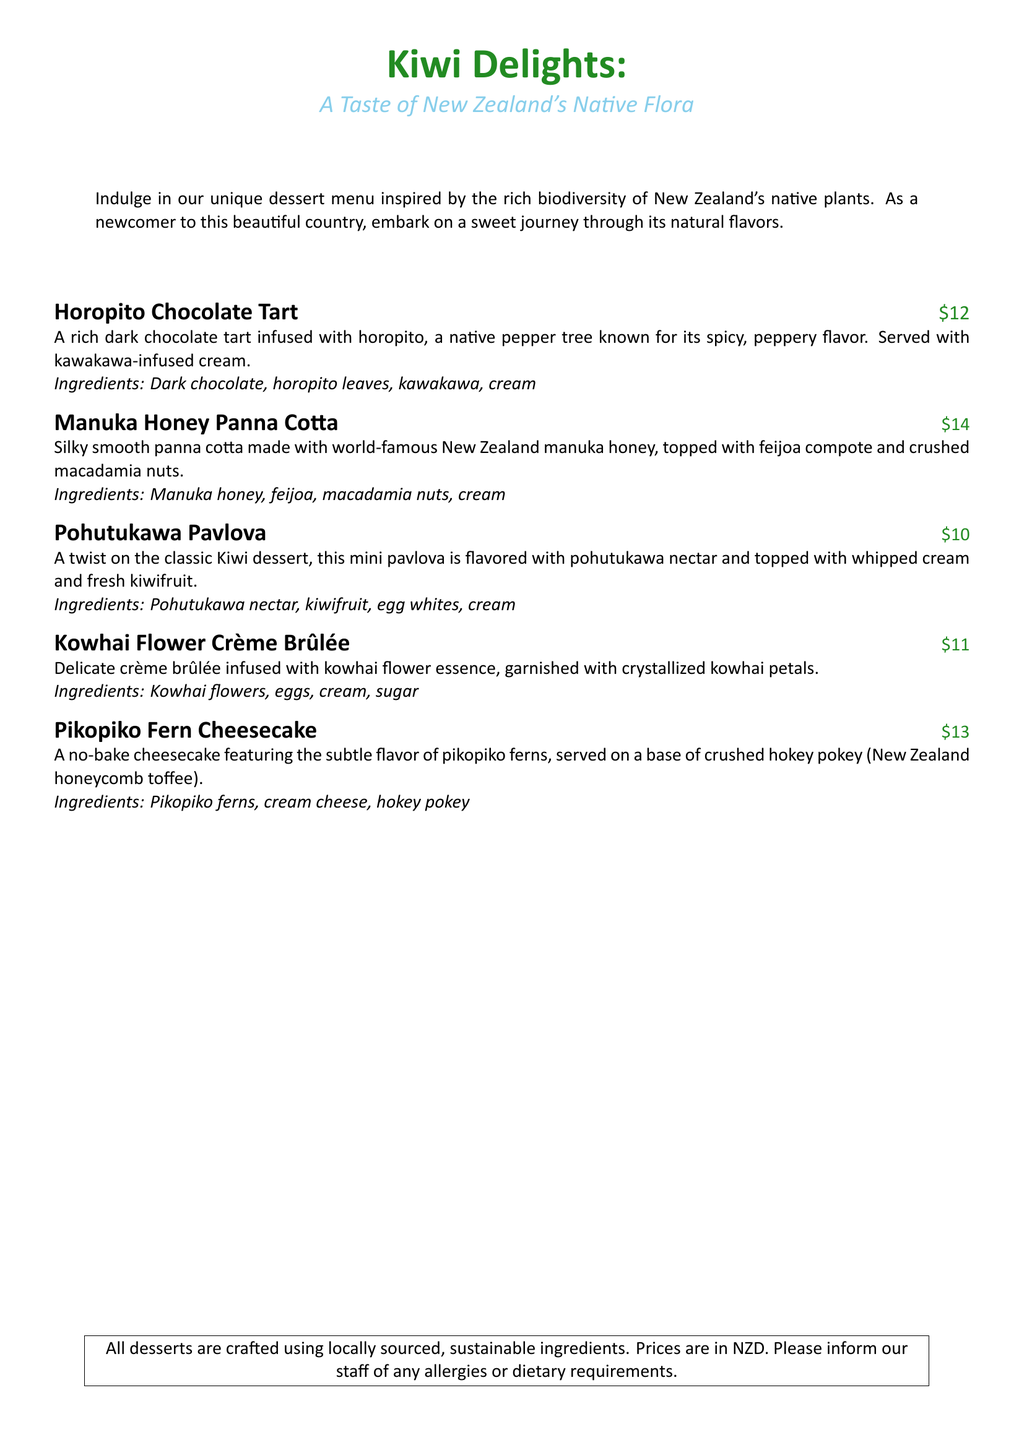what is the price of the Horopito Chocolate Tart? The price can be found next to the dessert name in the menu.
Answer: $12 which native plant is used in the Manuka Honey Panna Cotta? This dessert features world-famous New Zealand manuka honey as its key ingredient.
Answer: manuka honey what are the main ingredients of the Kowhai Flower Crème Brûlée? The ingredients for this dessert are listed after the description.
Answer: kowhai flowers, eggs, cream, sugar how is the Pohutukawa Pavlova different from the classic version? The description mentions a twist flavoring with a specific native nectar.
Answer: pohutukawa nectar what is the base ingredient used in the Pikopiko Fern Cheesecake? The menu specifies that this cheesecake is served on a base made of a particular type of toffee.
Answer: hokey pokey how many desserts are listed on the menu? The number of items can be counted from the list provided in the document.
Answer: 5 what kind of cream is served with the Horopito Chocolate Tart? The dessert's description mentions a specific type of cream paired with it.
Answer: kawakawa-infused cream what feature do all desserts share regarding ingredients? This information is provided as a note at the bottom of the menu.
Answer: locally sourced, sustainable ingredients 